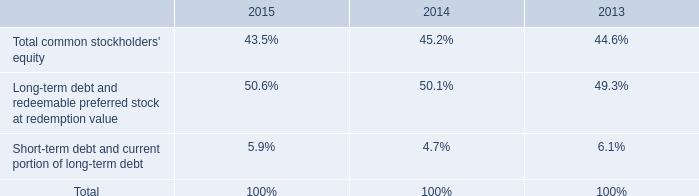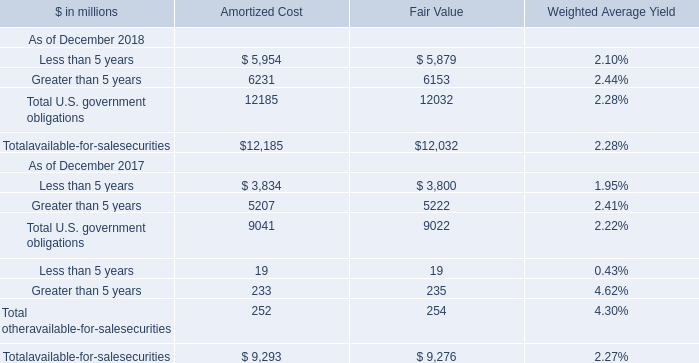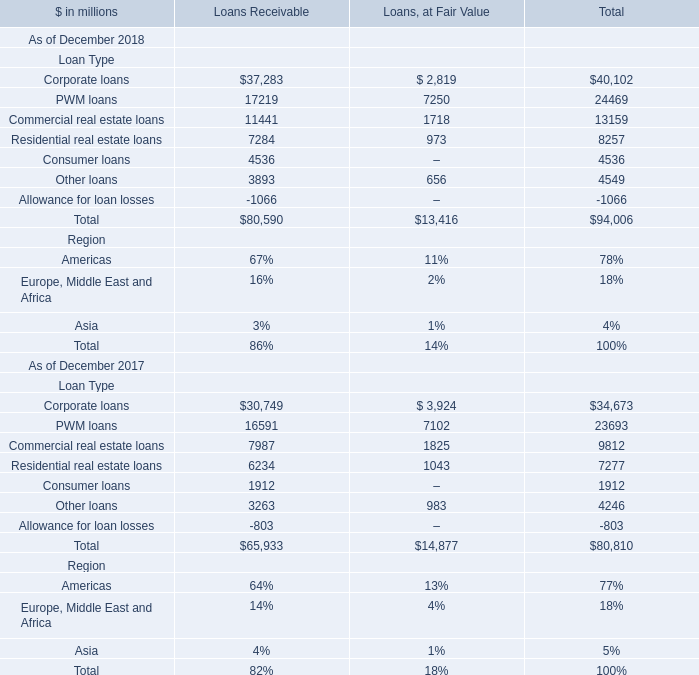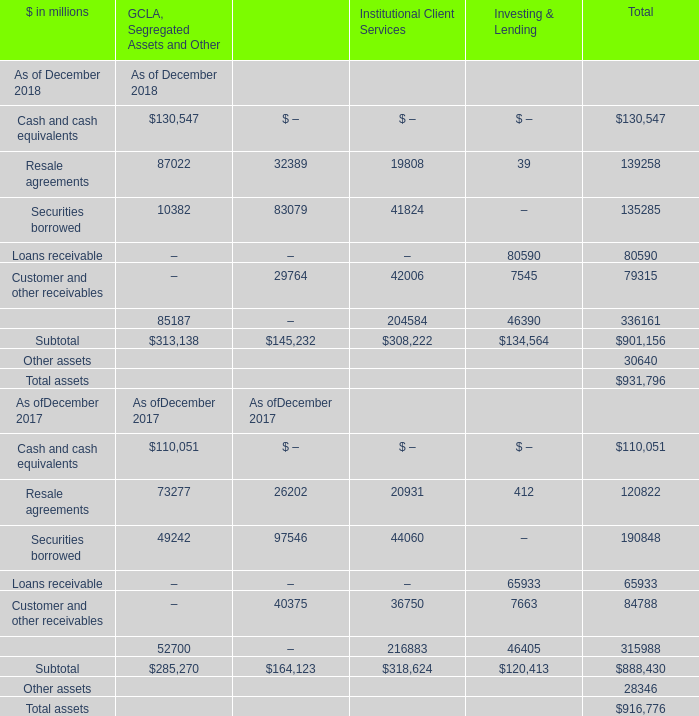What is the growing rate of Cash and cash equivalents for Total in the year with the most Loans receivable for Total? 
Computations: ((130547 - 110051) / 130547)
Answer: 0.157. 